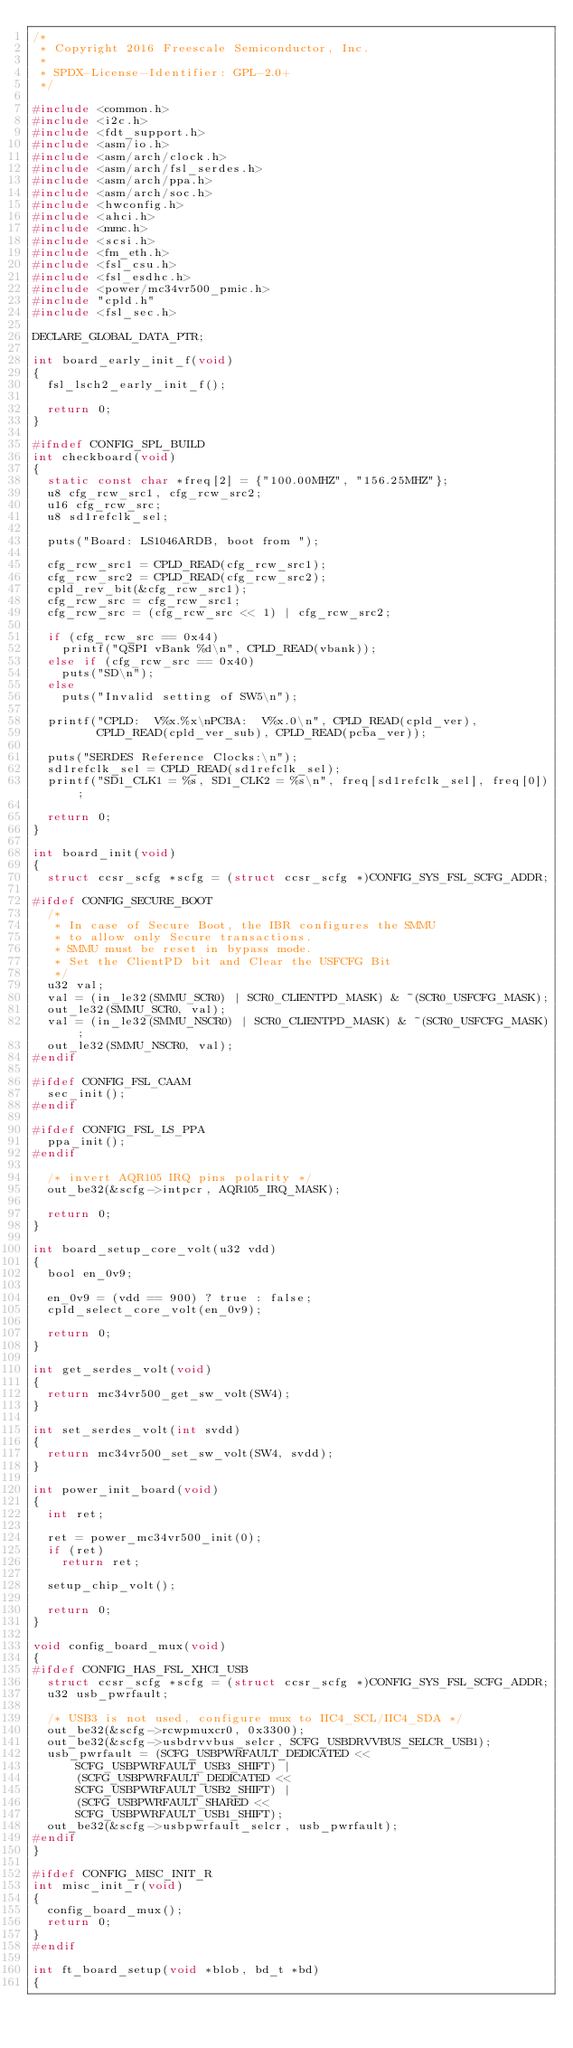<code> <loc_0><loc_0><loc_500><loc_500><_C_>/*
 * Copyright 2016 Freescale Semiconductor, Inc.
 *
 * SPDX-License-Identifier:	GPL-2.0+
 */

#include <common.h>
#include <i2c.h>
#include <fdt_support.h>
#include <asm/io.h>
#include <asm/arch/clock.h>
#include <asm/arch/fsl_serdes.h>
#include <asm/arch/ppa.h>
#include <asm/arch/soc.h>
#include <hwconfig.h>
#include <ahci.h>
#include <mmc.h>
#include <scsi.h>
#include <fm_eth.h>
#include <fsl_csu.h>
#include <fsl_esdhc.h>
#include <power/mc34vr500_pmic.h>
#include "cpld.h"
#include <fsl_sec.h>

DECLARE_GLOBAL_DATA_PTR;

int board_early_init_f(void)
{
	fsl_lsch2_early_init_f();

	return 0;
}

#ifndef CONFIG_SPL_BUILD
int checkboard(void)
{
	static const char *freq[2] = {"100.00MHZ", "156.25MHZ"};
	u8 cfg_rcw_src1, cfg_rcw_src2;
	u16 cfg_rcw_src;
	u8 sd1refclk_sel;

	puts("Board: LS1046ARDB, boot from ");

	cfg_rcw_src1 = CPLD_READ(cfg_rcw_src1);
	cfg_rcw_src2 = CPLD_READ(cfg_rcw_src2);
	cpld_rev_bit(&cfg_rcw_src1);
	cfg_rcw_src = cfg_rcw_src1;
	cfg_rcw_src = (cfg_rcw_src << 1) | cfg_rcw_src2;

	if (cfg_rcw_src == 0x44)
		printf("QSPI vBank %d\n", CPLD_READ(vbank));
	else if (cfg_rcw_src == 0x40)
		puts("SD\n");
	else
		puts("Invalid setting of SW5\n");

	printf("CPLD:  V%x.%x\nPCBA:  V%x.0\n", CPLD_READ(cpld_ver),
	       CPLD_READ(cpld_ver_sub), CPLD_READ(pcba_ver));

	puts("SERDES Reference Clocks:\n");
	sd1refclk_sel = CPLD_READ(sd1refclk_sel);
	printf("SD1_CLK1 = %s, SD1_CLK2 = %s\n", freq[sd1refclk_sel], freq[0]);

	return 0;
}

int board_init(void)
{
	struct ccsr_scfg *scfg = (struct ccsr_scfg *)CONFIG_SYS_FSL_SCFG_ADDR;

#ifdef CONFIG_SECURE_BOOT
	/*
	 * In case of Secure Boot, the IBR configures the SMMU
	 * to allow only Secure transactions.
	 * SMMU must be reset in bypass mode.
	 * Set the ClientPD bit and Clear the USFCFG Bit
	 */
	u32 val;
	val = (in_le32(SMMU_SCR0) | SCR0_CLIENTPD_MASK) & ~(SCR0_USFCFG_MASK);
	out_le32(SMMU_SCR0, val);
	val = (in_le32(SMMU_NSCR0) | SCR0_CLIENTPD_MASK) & ~(SCR0_USFCFG_MASK);
	out_le32(SMMU_NSCR0, val);
#endif

#ifdef CONFIG_FSL_CAAM
	sec_init();
#endif

#ifdef CONFIG_FSL_LS_PPA
	ppa_init();
#endif

	/* invert AQR105 IRQ pins polarity */
	out_be32(&scfg->intpcr, AQR105_IRQ_MASK);

	return 0;
}

int board_setup_core_volt(u32 vdd)
{
	bool en_0v9;

	en_0v9 = (vdd == 900) ? true : false;
	cpld_select_core_volt(en_0v9);

	return 0;
}

int get_serdes_volt(void)
{
	return mc34vr500_get_sw_volt(SW4);
}

int set_serdes_volt(int svdd)
{
	return mc34vr500_set_sw_volt(SW4, svdd);
}

int power_init_board(void)
{
	int ret;

	ret = power_mc34vr500_init(0);
	if (ret)
		return ret;

	setup_chip_volt();

	return 0;
}

void config_board_mux(void)
{
#ifdef CONFIG_HAS_FSL_XHCI_USB
	struct ccsr_scfg *scfg = (struct ccsr_scfg *)CONFIG_SYS_FSL_SCFG_ADDR;
	u32 usb_pwrfault;

	/* USB3 is not used, configure mux to IIC4_SCL/IIC4_SDA */
	out_be32(&scfg->rcwpmuxcr0, 0x3300);
	out_be32(&scfg->usbdrvvbus_selcr, SCFG_USBDRVVBUS_SELCR_USB1);
	usb_pwrfault = (SCFG_USBPWRFAULT_DEDICATED <<
			SCFG_USBPWRFAULT_USB3_SHIFT) |
			(SCFG_USBPWRFAULT_DEDICATED <<
			SCFG_USBPWRFAULT_USB2_SHIFT) |
			(SCFG_USBPWRFAULT_SHARED <<
			SCFG_USBPWRFAULT_USB1_SHIFT);
	out_be32(&scfg->usbpwrfault_selcr, usb_pwrfault);
#endif
}

#ifdef CONFIG_MISC_INIT_R
int misc_init_r(void)
{
	config_board_mux();
	return 0;
}
#endif

int ft_board_setup(void *blob, bd_t *bd)
{</code> 